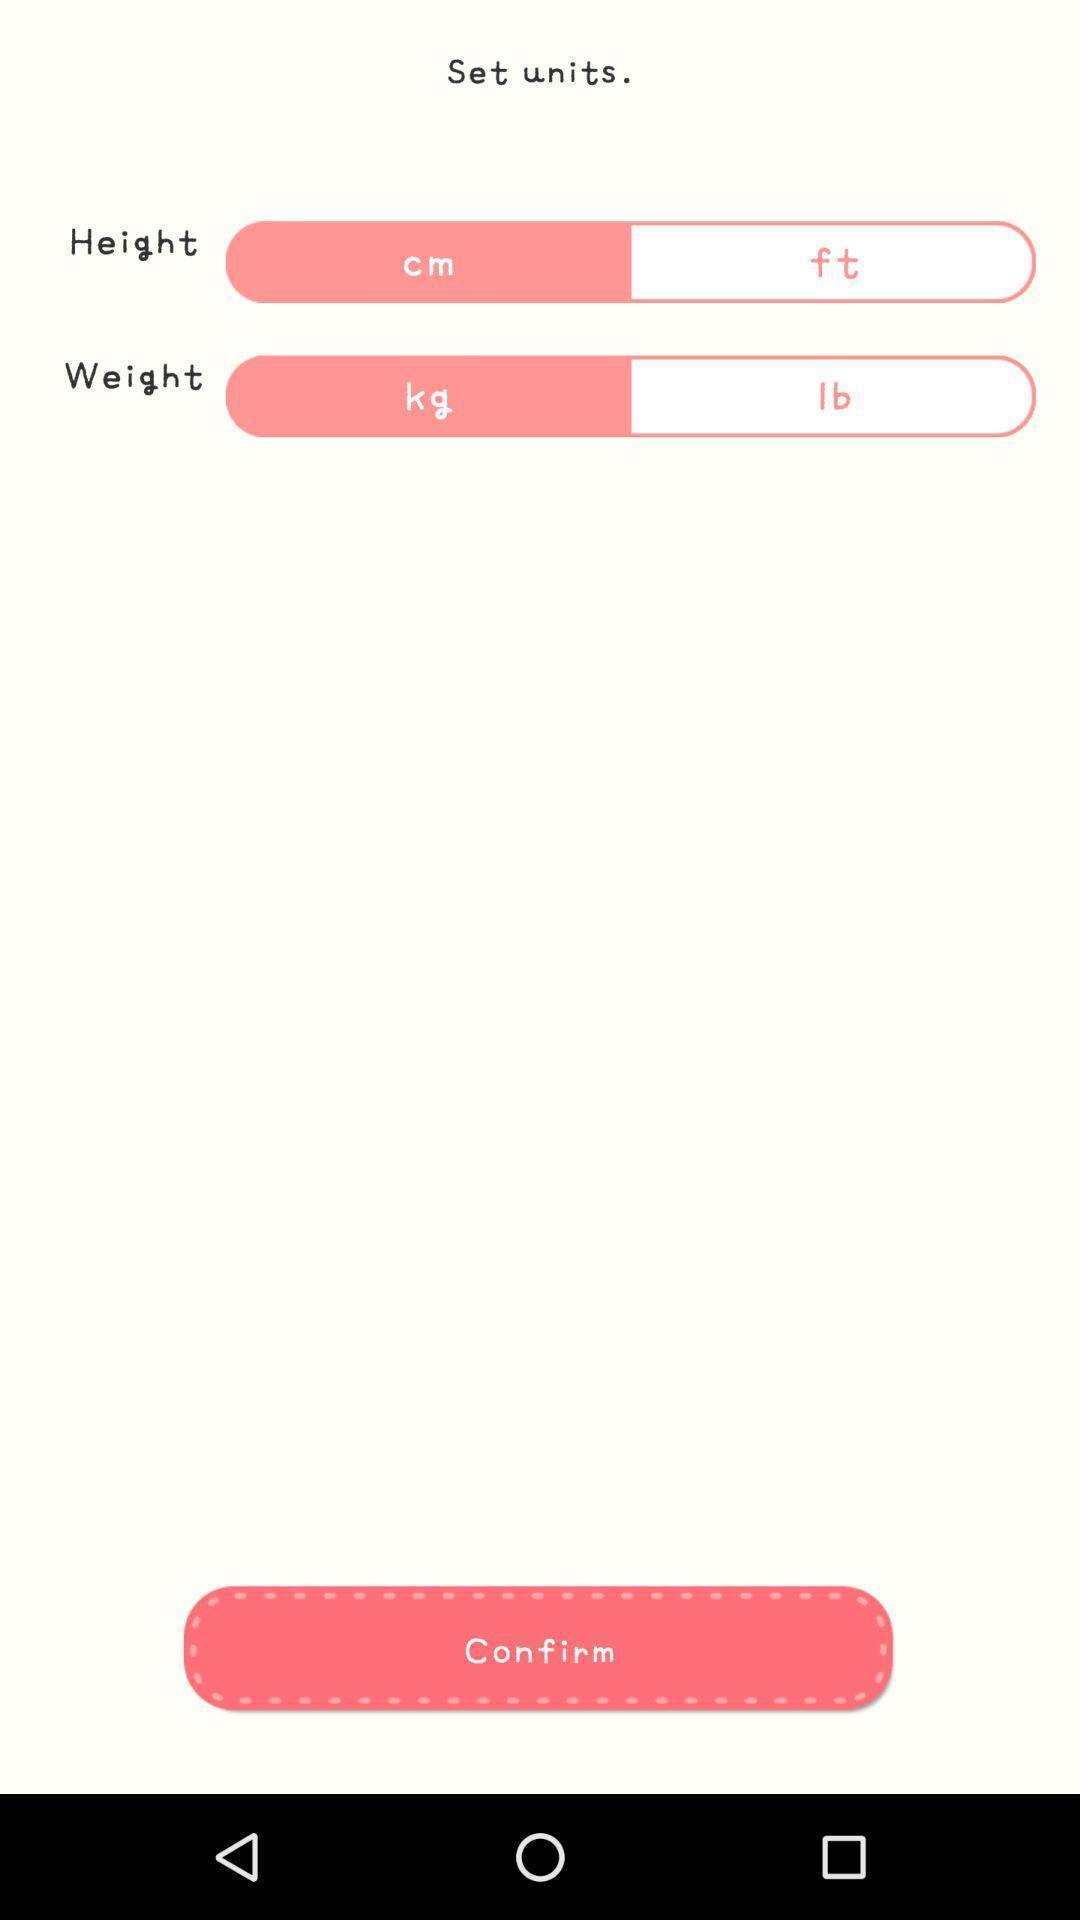Summarize the information in this screenshot. Page displaying to set units. 